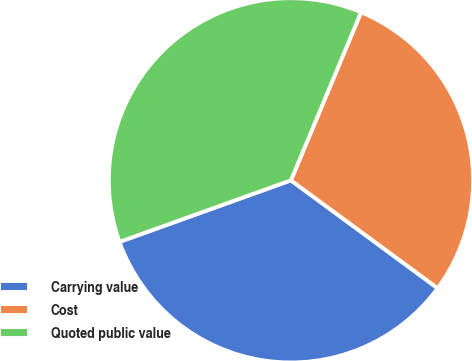Convert chart to OTSL. <chart><loc_0><loc_0><loc_500><loc_500><pie_chart><fcel>Carrying value<fcel>Cost<fcel>Quoted public value<nl><fcel>34.42%<fcel>28.8%<fcel>36.78%<nl></chart> 